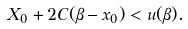Convert formula to latex. <formula><loc_0><loc_0><loc_500><loc_500>X _ { 0 } + 2 C ( \beta - x _ { 0 } ) < u ( \beta ) .</formula> 